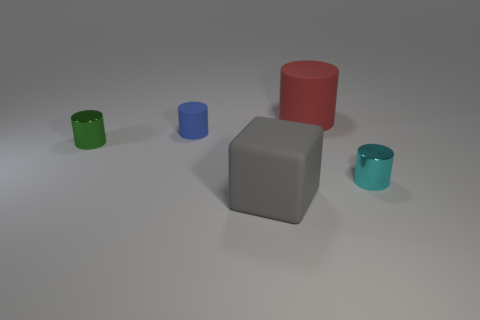What number of tiny blue cylinders are there?
Make the answer very short. 1. How many large objects are either green objects or rubber cubes?
Your response must be concise. 1. There is a tiny metal cylinder right of the shiny cylinder that is on the left side of the large matte object that is in front of the tiny green shiny thing; what is its color?
Make the answer very short. Cyan. What number of other objects are the same color as the block?
Your answer should be very brief. 0. How many shiny objects are big brown cylinders or large gray blocks?
Offer a very short reply. 0. Are there any other things that have the same material as the big gray thing?
Make the answer very short. Yes. What size is the red object that is the same shape as the blue rubber object?
Your answer should be very brief. Large. Are there more objects behind the small cyan cylinder than small matte things?
Provide a short and direct response. Yes. Are the small cylinder that is on the right side of the gray cube and the small green cylinder made of the same material?
Provide a succinct answer. Yes. What size is the rubber object that is in front of the shiny cylinder that is to the left of the large object that is behind the small cyan object?
Provide a short and direct response. Large. 